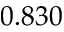Convert formula to latex. <formula><loc_0><loc_0><loc_500><loc_500>0 . 8 3 0</formula> 